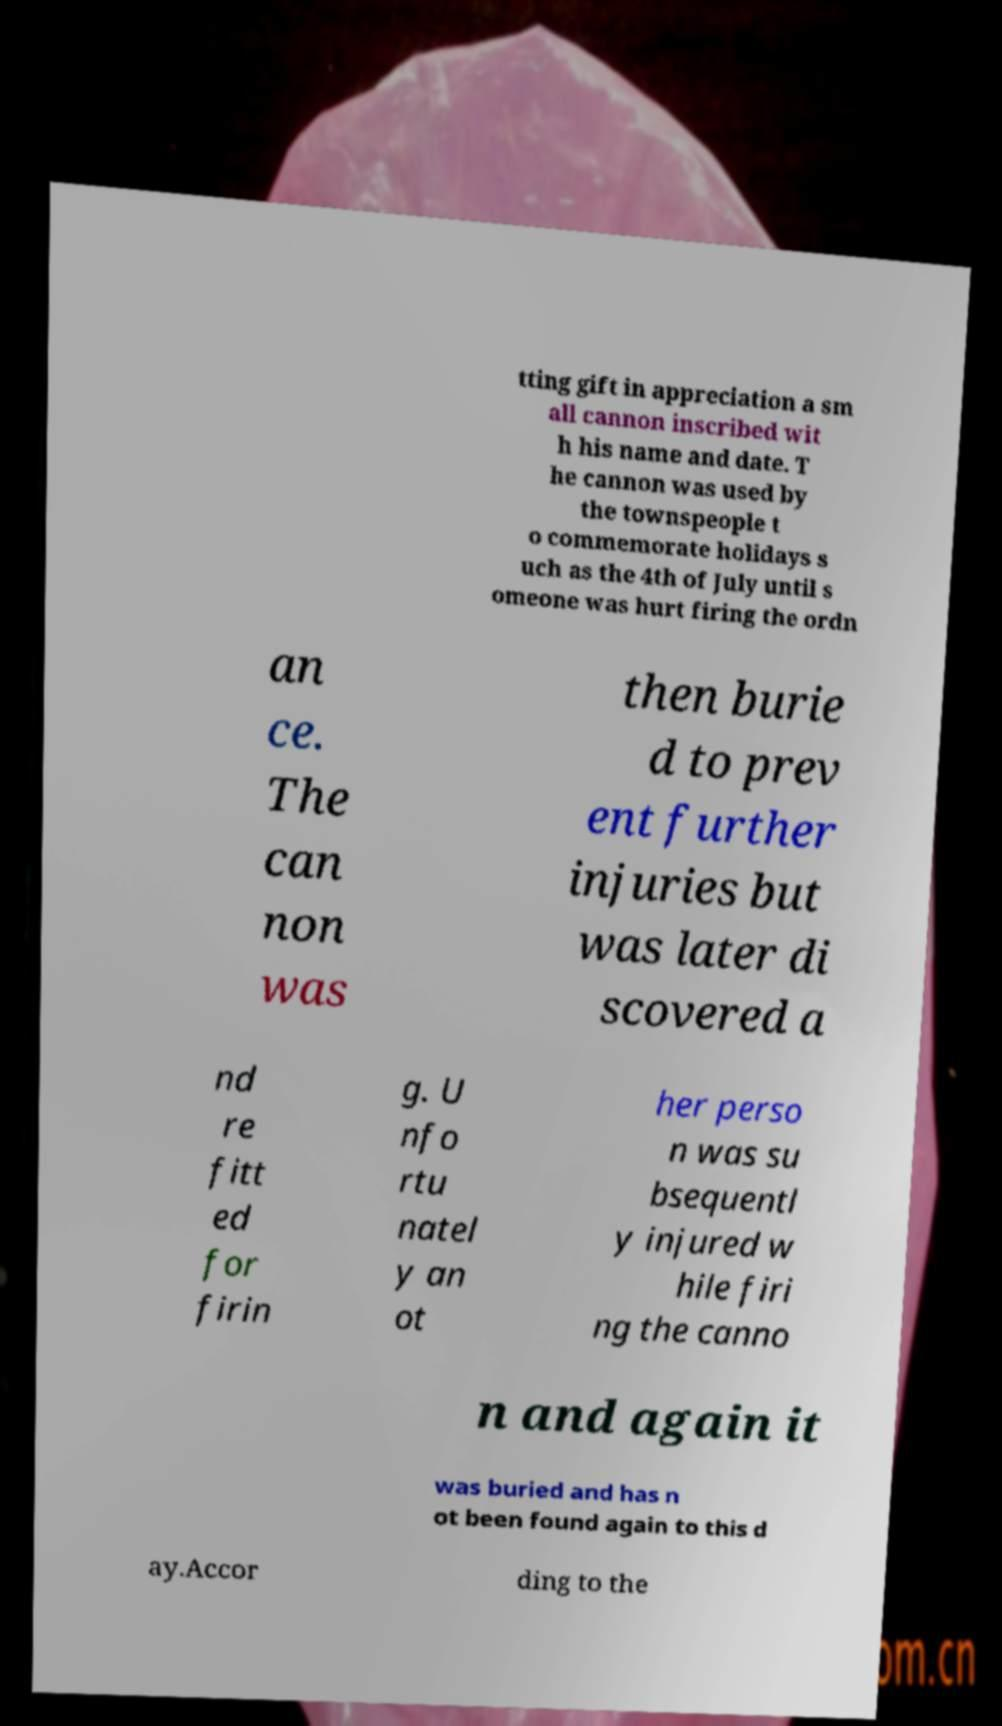Please identify and transcribe the text found in this image. tting gift in appreciation a sm all cannon inscribed wit h his name and date. T he cannon was used by the townspeople t o commemorate holidays s uch as the 4th of July until s omeone was hurt firing the ordn an ce. The can non was then burie d to prev ent further injuries but was later di scovered a nd re fitt ed for firin g. U nfo rtu natel y an ot her perso n was su bsequentl y injured w hile firi ng the canno n and again it was buried and has n ot been found again to this d ay.Accor ding to the 